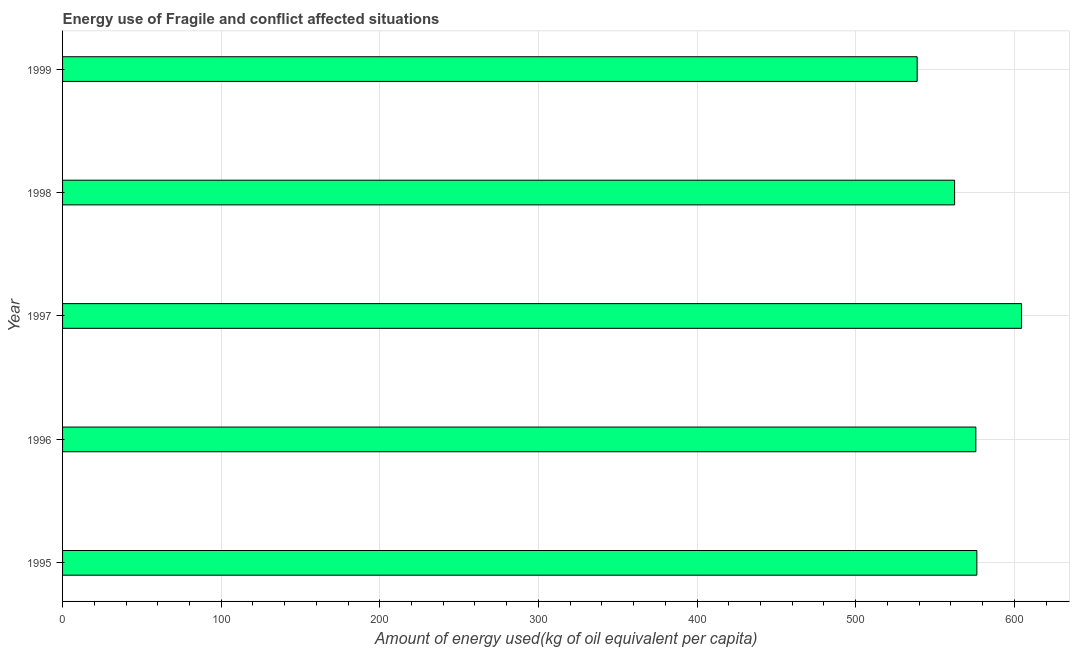Does the graph contain any zero values?
Offer a very short reply. No. Does the graph contain grids?
Offer a very short reply. Yes. What is the title of the graph?
Provide a short and direct response. Energy use of Fragile and conflict affected situations. What is the label or title of the X-axis?
Give a very brief answer. Amount of energy used(kg of oil equivalent per capita). What is the amount of energy used in 1999?
Make the answer very short. 538.75. Across all years, what is the maximum amount of energy used?
Offer a terse response. 604.56. Across all years, what is the minimum amount of energy used?
Give a very brief answer. 538.75. In which year was the amount of energy used maximum?
Ensure brevity in your answer.  1997. What is the sum of the amount of energy used?
Provide a short and direct response. 2857.79. What is the difference between the amount of energy used in 1995 and 1996?
Provide a short and direct response. 0.64. What is the average amount of energy used per year?
Your response must be concise. 571.56. What is the median amount of energy used?
Your answer should be very brief. 575.74. In how many years, is the amount of energy used greater than 60 kg?
Your response must be concise. 5. Do a majority of the years between 1999 and 1996 (inclusive) have amount of energy used greater than 20 kg?
Your response must be concise. Yes. What is the ratio of the amount of energy used in 1996 to that in 1999?
Your answer should be very brief. 1.07. What is the difference between the highest and the second highest amount of energy used?
Offer a very short reply. 28.17. What is the difference between the highest and the lowest amount of energy used?
Your response must be concise. 65.81. In how many years, is the amount of energy used greater than the average amount of energy used taken over all years?
Your answer should be very brief. 3. How many bars are there?
Offer a very short reply. 5. Are all the bars in the graph horizontal?
Offer a very short reply. Yes. How many years are there in the graph?
Give a very brief answer. 5. What is the difference between two consecutive major ticks on the X-axis?
Offer a very short reply. 100. Are the values on the major ticks of X-axis written in scientific E-notation?
Offer a terse response. No. What is the Amount of energy used(kg of oil equivalent per capita) of 1995?
Ensure brevity in your answer.  576.38. What is the Amount of energy used(kg of oil equivalent per capita) in 1996?
Ensure brevity in your answer.  575.74. What is the Amount of energy used(kg of oil equivalent per capita) in 1997?
Offer a very short reply. 604.56. What is the Amount of energy used(kg of oil equivalent per capita) of 1998?
Make the answer very short. 562.35. What is the Amount of energy used(kg of oil equivalent per capita) in 1999?
Your answer should be very brief. 538.75. What is the difference between the Amount of energy used(kg of oil equivalent per capita) in 1995 and 1996?
Your answer should be very brief. 0.64. What is the difference between the Amount of energy used(kg of oil equivalent per capita) in 1995 and 1997?
Make the answer very short. -28.17. What is the difference between the Amount of energy used(kg of oil equivalent per capita) in 1995 and 1998?
Provide a short and direct response. 14.03. What is the difference between the Amount of energy used(kg of oil equivalent per capita) in 1995 and 1999?
Make the answer very short. 37.64. What is the difference between the Amount of energy used(kg of oil equivalent per capita) in 1996 and 1997?
Offer a very short reply. -28.81. What is the difference between the Amount of energy used(kg of oil equivalent per capita) in 1996 and 1998?
Ensure brevity in your answer.  13.39. What is the difference between the Amount of energy used(kg of oil equivalent per capita) in 1996 and 1999?
Offer a terse response. 37. What is the difference between the Amount of energy used(kg of oil equivalent per capita) in 1997 and 1998?
Offer a terse response. 42.2. What is the difference between the Amount of energy used(kg of oil equivalent per capita) in 1997 and 1999?
Offer a very short reply. 65.81. What is the difference between the Amount of energy used(kg of oil equivalent per capita) in 1998 and 1999?
Ensure brevity in your answer.  23.61. What is the ratio of the Amount of energy used(kg of oil equivalent per capita) in 1995 to that in 1997?
Provide a short and direct response. 0.95. What is the ratio of the Amount of energy used(kg of oil equivalent per capita) in 1995 to that in 1999?
Provide a succinct answer. 1.07. What is the ratio of the Amount of energy used(kg of oil equivalent per capita) in 1996 to that in 1998?
Your response must be concise. 1.02. What is the ratio of the Amount of energy used(kg of oil equivalent per capita) in 1996 to that in 1999?
Provide a succinct answer. 1.07. What is the ratio of the Amount of energy used(kg of oil equivalent per capita) in 1997 to that in 1998?
Offer a very short reply. 1.07. What is the ratio of the Amount of energy used(kg of oil equivalent per capita) in 1997 to that in 1999?
Give a very brief answer. 1.12. What is the ratio of the Amount of energy used(kg of oil equivalent per capita) in 1998 to that in 1999?
Ensure brevity in your answer.  1.04. 